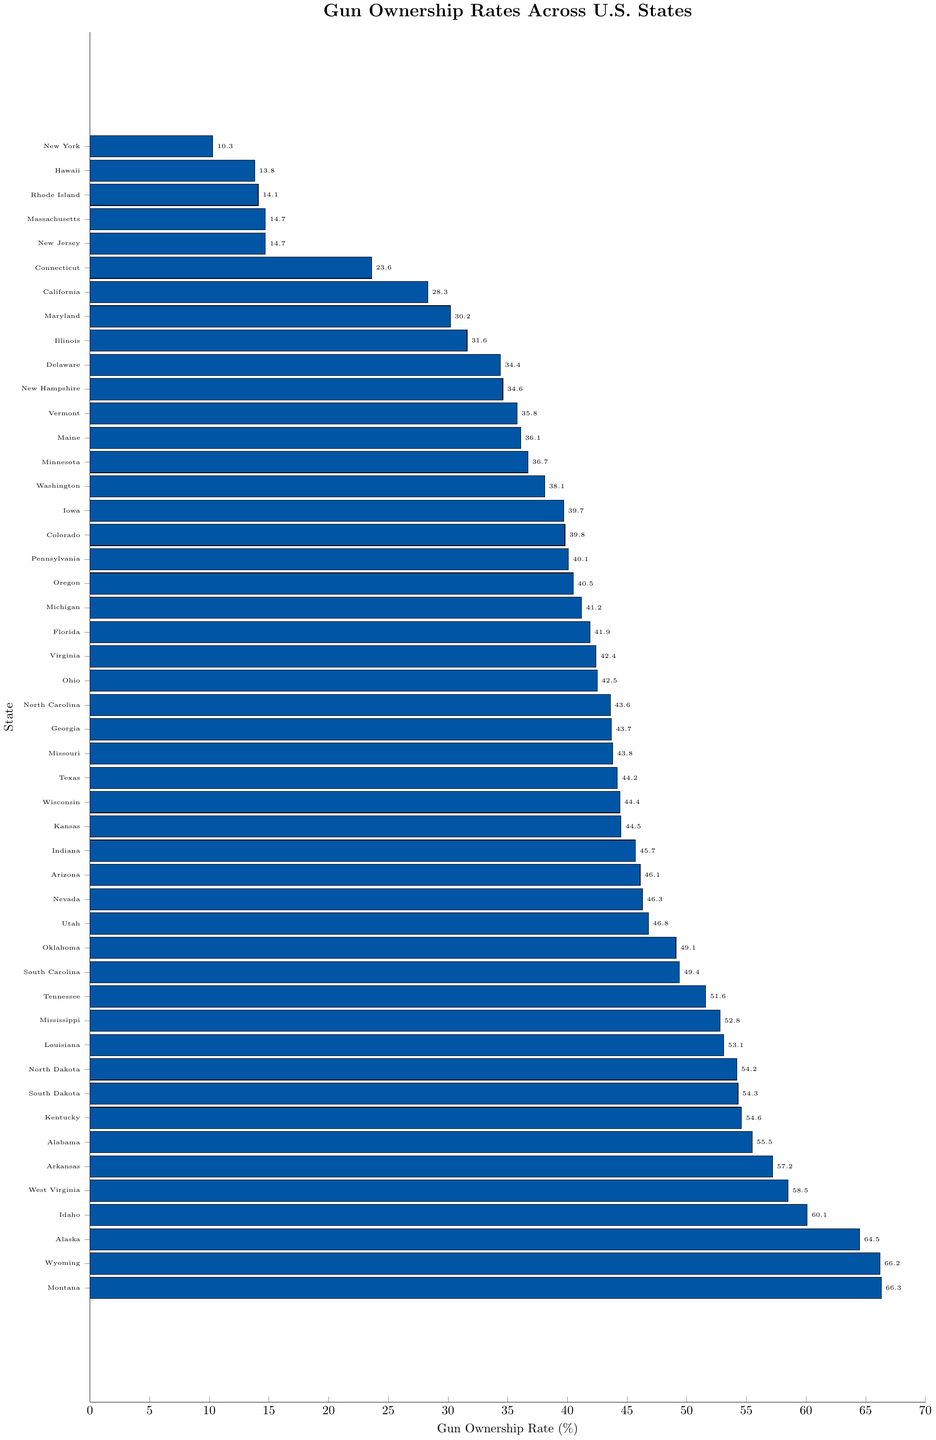What state has the highest gun ownership rate? The bar for the state with the highest rate extends the farthest to the right.
Answer: Montana Which state has a gun ownership rate of 45.7%? Look for the bar that ends at 45.7%. The state name next to that bar is the answer.
Answer: Indiana Compare the gun ownership rates of Texas and California. Which state has a higher rate? Identify the bars representing Texas and California. Texas's bar is longer than California's.
Answer: Texas What's the difference in gun ownership rates between Alaska and Hawaii? Subtract the gun ownership rate of Hawaii from that of Alaska: 64.5% - 13.8% = 50.7%.
Answer: 50.7% Is the gun ownership rate of New York more or less than 20%? Look at the bar representing New York and check if it extends past 20%.
Answer: Less What is the median gun ownership rate among all states? To find the median, list all states' rates in ascending order and pick the middle one. The middle value of the sorted list is the median. There are 50 states, so the median is the average of the 25th and 26th values. These values are 43.8% (Missouri) and 44.2% (Texas), so the median is (43.8 + 44.2) / 2 = 44.0%.
Answer: 44.0% Are there more states with a gun ownership rate above or below 50%? Count the number of bars with values above 50% and below 50%.
Answer: Below Which states have gun ownership rates between 40% and 50%? Identify the bars whose lengths correspond to rates within this range: Pennsylvania, Florida, Michigan, Oregon, Texas, Wisconsin, Kansas, Indiana, Arizona, Nevada, Utah, Oklahoma, South Carolina, North Carolina, Ohio, and Virginia.
Answer: Pennsylvania, Florida, Michigan, Oregon, Texas, Wisconsin, Kansas, Indiana, Arizona, Nevada, Utah, Oklahoma, South Carolina, North Carolina, Ohio, Virginia What is the combined gun ownership rate of the top three states? Sum the rates of the top three states: Montana (66.3%), Wyoming (66.2%), and Alaska (64.5%): 66.3 + 66.2 + 64.5 = 197.0%.
Answer: 197.0% How many states have gun ownership rates less than 15%? Count the number of bars that end below the 15% mark.
Answer: 4 